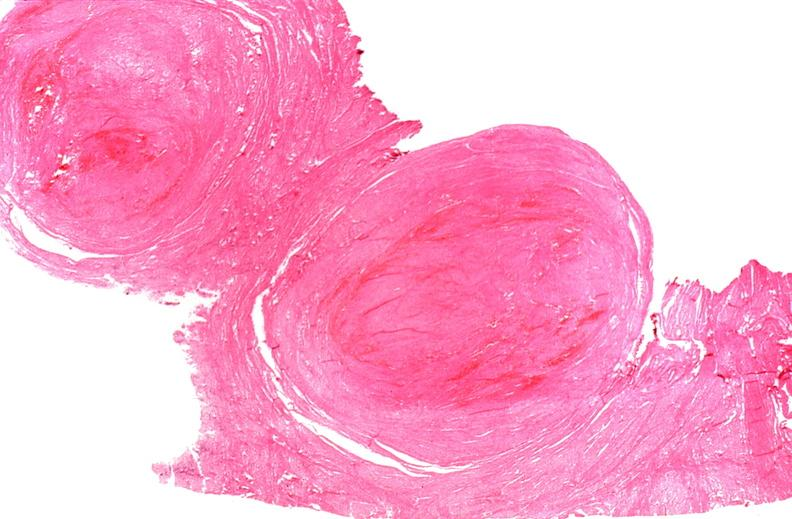does this image show uterus, leiomyomas?
Answer the question using a single word or phrase. Yes 